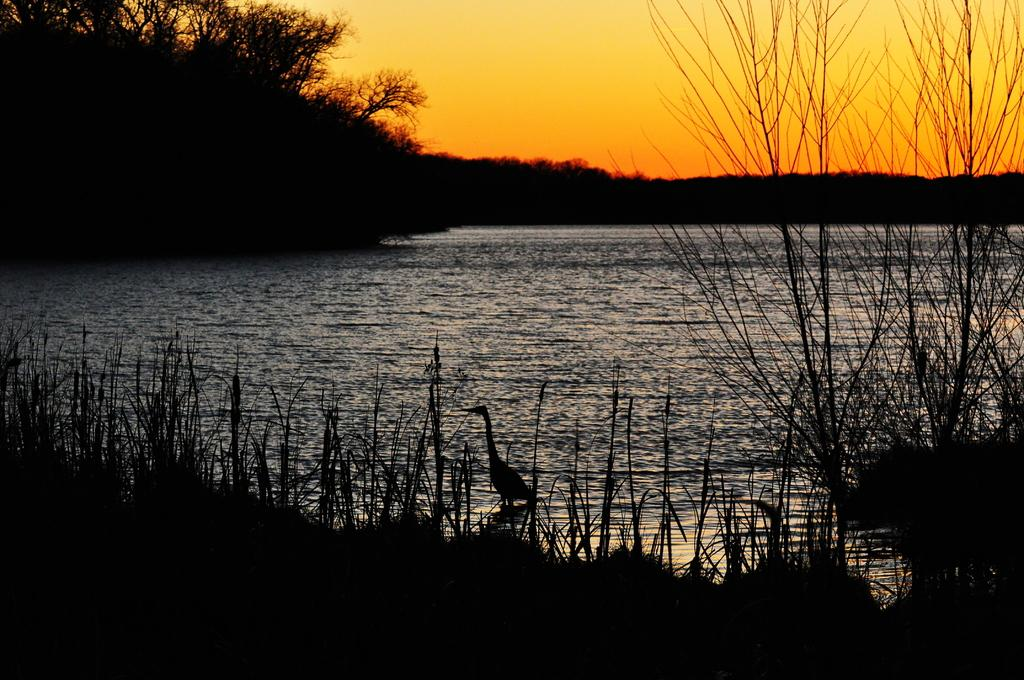What type of animal can be seen in the image? There is a bird in the image. Where is the bird located? The bird is in the water. What else is present in the image besides the bird? There are plants in the image. What is the color of the sky in the background of the image? The sky is orange in the background of the image. What type of lunch is the bird eating in the image? There is no indication of a lunch or any food in the image; it simply shows a bird in the water. 